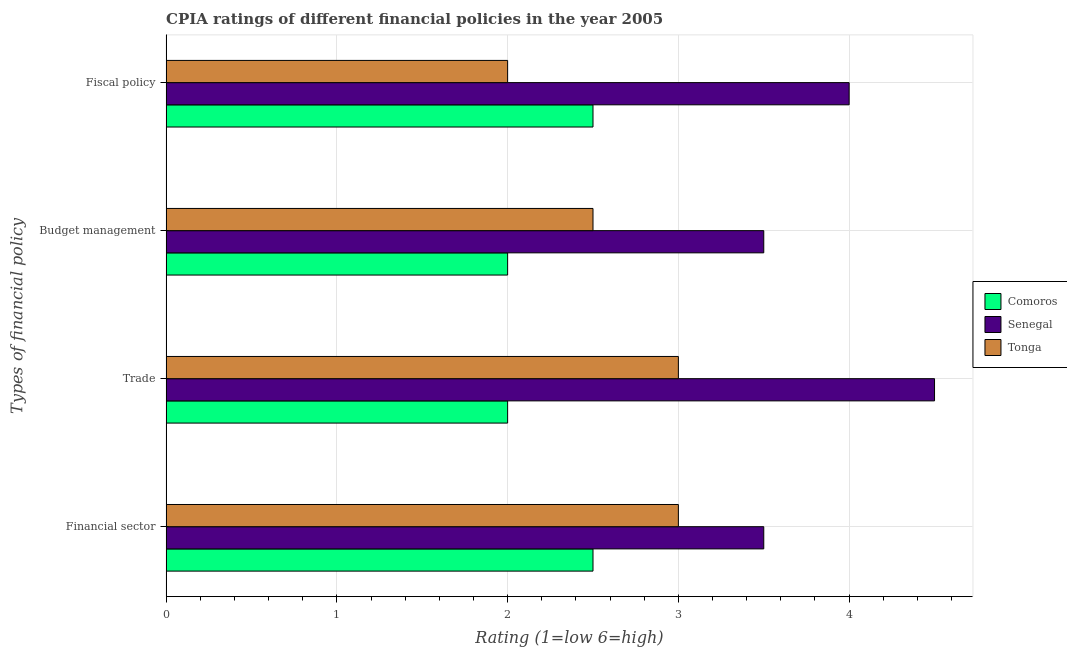How many groups of bars are there?
Your answer should be compact. 4. Are the number of bars per tick equal to the number of legend labels?
Your response must be concise. Yes. How many bars are there on the 1st tick from the top?
Provide a succinct answer. 3. What is the label of the 4th group of bars from the top?
Your answer should be compact. Financial sector. What is the cpia rating of financial sector in Tonga?
Your answer should be compact. 3. Across all countries, what is the minimum cpia rating of trade?
Your response must be concise. 2. In which country was the cpia rating of fiscal policy maximum?
Your answer should be compact. Senegal. In which country was the cpia rating of trade minimum?
Make the answer very short. Comoros. What is the total cpia rating of budget management in the graph?
Ensure brevity in your answer.  8. What is the average cpia rating of financial sector per country?
Make the answer very short. 3. What is the difference between the cpia rating of budget management and cpia rating of fiscal policy in Tonga?
Give a very brief answer. 0.5. What is the ratio of the cpia rating of budget management in Senegal to that in Tonga?
Make the answer very short. 1.4. Is the cpia rating of budget management in Comoros less than that in Senegal?
Provide a succinct answer. Yes. What is the difference between the highest and the second highest cpia rating of trade?
Offer a terse response. 1.5. What is the difference between the highest and the lowest cpia rating of fiscal policy?
Offer a terse response. 2. What does the 2nd bar from the top in Trade represents?
Keep it short and to the point. Senegal. What does the 3rd bar from the bottom in Fiscal policy represents?
Provide a succinct answer. Tonga. Is it the case that in every country, the sum of the cpia rating of financial sector and cpia rating of trade is greater than the cpia rating of budget management?
Ensure brevity in your answer.  Yes. How many bars are there?
Make the answer very short. 12. Are all the bars in the graph horizontal?
Offer a terse response. Yes. How many countries are there in the graph?
Your response must be concise. 3. Does the graph contain any zero values?
Your answer should be very brief. No. What is the title of the graph?
Make the answer very short. CPIA ratings of different financial policies in the year 2005. Does "Azerbaijan" appear as one of the legend labels in the graph?
Offer a terse response. No. What is the label or title of the X-axis?
Keep it short and to the point. Rating (1=low 6=high). What is the label or title of the Y-axis?
Give a very brief answer. Types of financial policy. What is the Rating (1=low 6=high) in Senegal in Financial sector?
Ensure brevity in your answer.  3.5. What is the Rating (1=low 6=high) of Tonga in Financial sector?
Give a very brief answer. 3. What is the Rating (1=low 6=high) of Comoros in Trade?
Provide a succinct answer. 2. What is the Rating (1=low 6=high) in Comoros in Budget management?
Provide a short and direct response. 2. What is the Rating (1=low 6=high) in Tonga in Fiscal policy?
Provide a short and direct response. 2. Across all Types of financial policy, what is the maximum Rating (1=low 6=high) in Senegal?
Give a very brief answer. 4.5. Across all Types of financial policy, what is the minimum Rating (1=low 6=high) in Comoros?
Your answer should be very brief. 2. Across all Types of financial policy, what is the minimum Rating (1=low 6=high) of Tonga?
Provide a short and direct response. 2. What is the total Rating (1=low 6=high) in Comoros in the graph?
Your response must be concise. 9. What is the difference between the Rating (1=low 6=high) of Senegal in Financial sector and that in Trade?
Your answer should be very brief. -1. What is the difference between the Rating (1=low 6=high) of Comoros in Financial sector and that in Budget management?
Your response must be concise. 0.5. What is the difference between the Rating (1=low 6=high) in Senegal in Financial sector and that in Budget management?
Make the answer very short. 0. What is the difference between the Rating (1=low 6=high) in Senegal in Financial sector and that in Fiscal policy?
Provide a succinct answer. -0.5. What is the difference between the Rating (1=low 6=high) of Tonga in Financial sector and that in Fiscal policy?
Make the answer very short. 1. What is the difference between the Rating (1=low 6=high) in Senegal in Trade and that in Budget management?
Provide a succinct answer. 1. What is the difference between the Rating (1=low 6=high) in Tonga in Trade and that in Budget management?
Offer a very short reply. 0.5. What is the difference between the Rating (1=low 6=high) in Tonga in Trade and that in Fiscal policy?
Give a very brief answer. 1. What is the difference between the Rating (1=low 6=high) in Senegal in Budget management and that in Fiscal policy?
Offer a very short reply. -0.5. What is the difference between the Rating (1=low 6=high) of Senegal in Financial sector and the Rating (1=low 6=high) of Tonga in Trade?
Your answer should be very brief. 0.5. What is the difference between the Rating (1=low 6=high) in Comoros in Financial sector and the Rating (1=low 6=high) in Senegal in Budget management?
Keep it short and to the point. -1. What is the difference between the Rating (1=low 6=high) of Senegal in Financial sector and the Rating (1=low 6=high) of Tonga in Budget management?
Make the answer very short. 1. What is the difference between the Rating (1=low 6=high) in Comoros in Financial sector and the Rating (1=low 6=high) in Senegal in Fiscal policy?
Your response must be concise. -1.5. What is the difference between the Rating (1=low 6=high) of Comoros in Trade and the Rating (1=low 6=high) of Senegal in Budget management?
Provide a short and direct response. -1.5. What is the difference between the Rating (1=low 6=high) of Comoros in Trade and the Rating (1=low 6=high) of Tonga in Budget management?
Provide a short and direct response. -0.5. What is the difference between the Rating (1=low 6=high) of Comoros in Trade and the Rating (1=low 6=high) of Senegal in Fiscal policy?
Your answer should be very brief. -2. What is the difference between the Rating (1=low 6=high) in Comoros in Trade and the Rating (1=low 6=high) in Tonga in Fiscal policy?
Make the answer very short. 0. What is the difference between the Rating (1=low 6=high) in Senegal in Trade and the Rating (1=low 6=high) in Tonga in Fiscal policy?
Your response must be concise. 2.5. What is the difference between the Rating (1=low 6=high) of Comoros in Budget management and the Rating (1=low 6=high) of Senegal in Fiscal policy?
Offer a very short reply. -2. What is the average Rating (1=low 6=high) of Comoros per Types of financial policy?
Provide a succinct answer. 2.25. What is the average Rating (1=low 6=high) of Senegal per Types of financial policy?
Provide a succinct answer. 3.88. What is the average Rating (1=low 6=high) of Tonga per Types of financial policy?
Keep it short and to the point. 2.62. What is the difference between the Rating (1=low 6=high) of Comoros and Rating (1=low 6=high) of Senegal in Financial sector?
Ensure brevity in your answer.  -1. What is the difference between the Rating (1=low 6=high) of Comoros and Rating (1=low 6=high) of Senegal in Trade?
Give a very brief answer. -2.5. What is the difference between the Rating (1=low 6=high) of Comoros and Rating (1=low 6=high) of Senegal in Budget management?
Keep it short and to the point. -1.5. What is the difference between the Rating (1=low 6=high) in Senegal and Rating (1=low 6=high) in Tonga in Budget management?
Offer a very short reply. 1. What is the difference between the Rating (1=low 6=high) in Senegal and Rating (1=low 6=high) in Tonga in Fiscal policy?
Offer a very short reply. 2. What is the ratio of the Rating (1=low 6=high) of Comoros in Financial sector to that in Budget management?
Keep it short and to the point. 1.25. What is the ratio of the Rating (1=low 6=high) in Tonga in Financial sector to that in Budget management?
Give a very brief answer. 1.2. What is the ratio of the Rating (1=low 6=high) of Tonga in Financial sector to that in Fiscal policy?
Keep it short and to the point. 1.5. What is the ratio of the Rating (1=low 6=high) in Senegal in Budget management to that in Fiscal policy?
Provide a succinct answer. 0.88. What is the ratio of the Rating (1=low 6=high) in Tonga in Budget management to that in Fiscal policy?
Ensure brevity in your answer.  1.25. What is the difference between the highest and the second highest Rating (1=low 6=high) of Comoros?
Your answer should be compact. 0. What is the difference between the highest and the second highest Rating (1=low 6=high) in Tonga?
Your response must be concise. 0. What is the difference between the highest and the lowest Rating (1=low 6=high) in Senegal?
Provide a succinct answer. 1. What is the difference between the highest and the lowest Rating (1=low 6=high) in Tonga?
Keep it short and to the point. 1. 